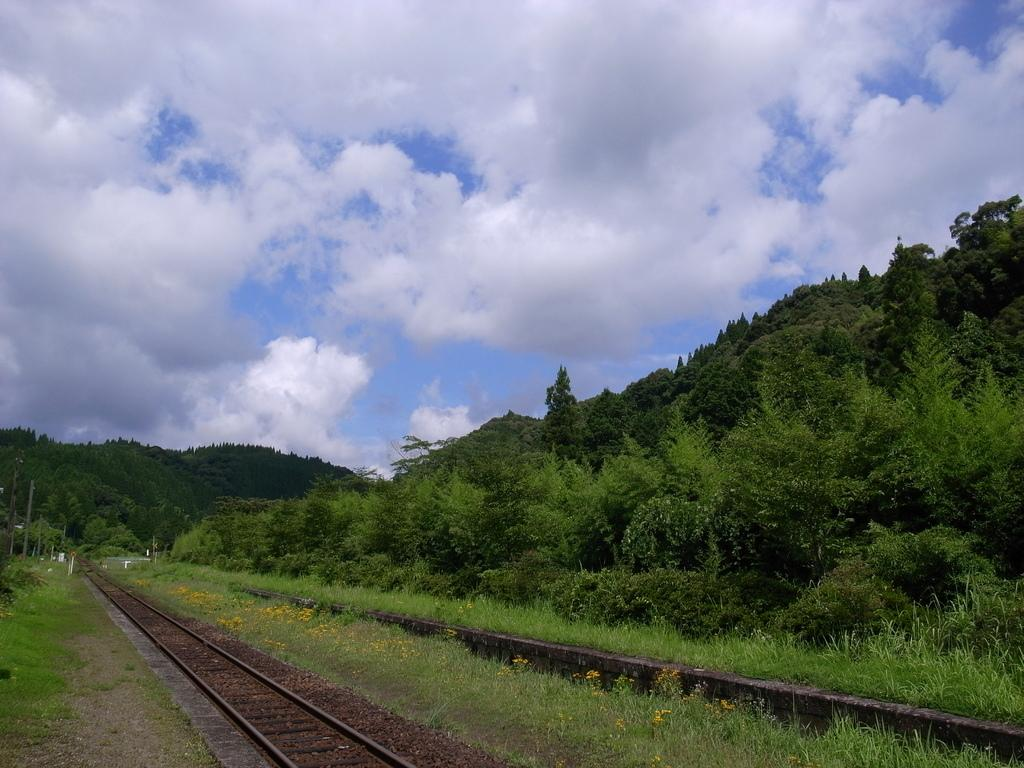What is the main feature in the center of the image? There is a railway track in the center of the image. What type of vegetation can be seen in the image? There is grass visible in the image. What can be seen in the background of the image? There are plants and the sky visible in the background of the image. What is the condition of the sky in the image? Clouds are present in the sky. What type of selection process is taking place at the railway track in the image? There is no indication of a selection process taking place in the image; it simply shows a railway track with surrounding vegetation and sky. 